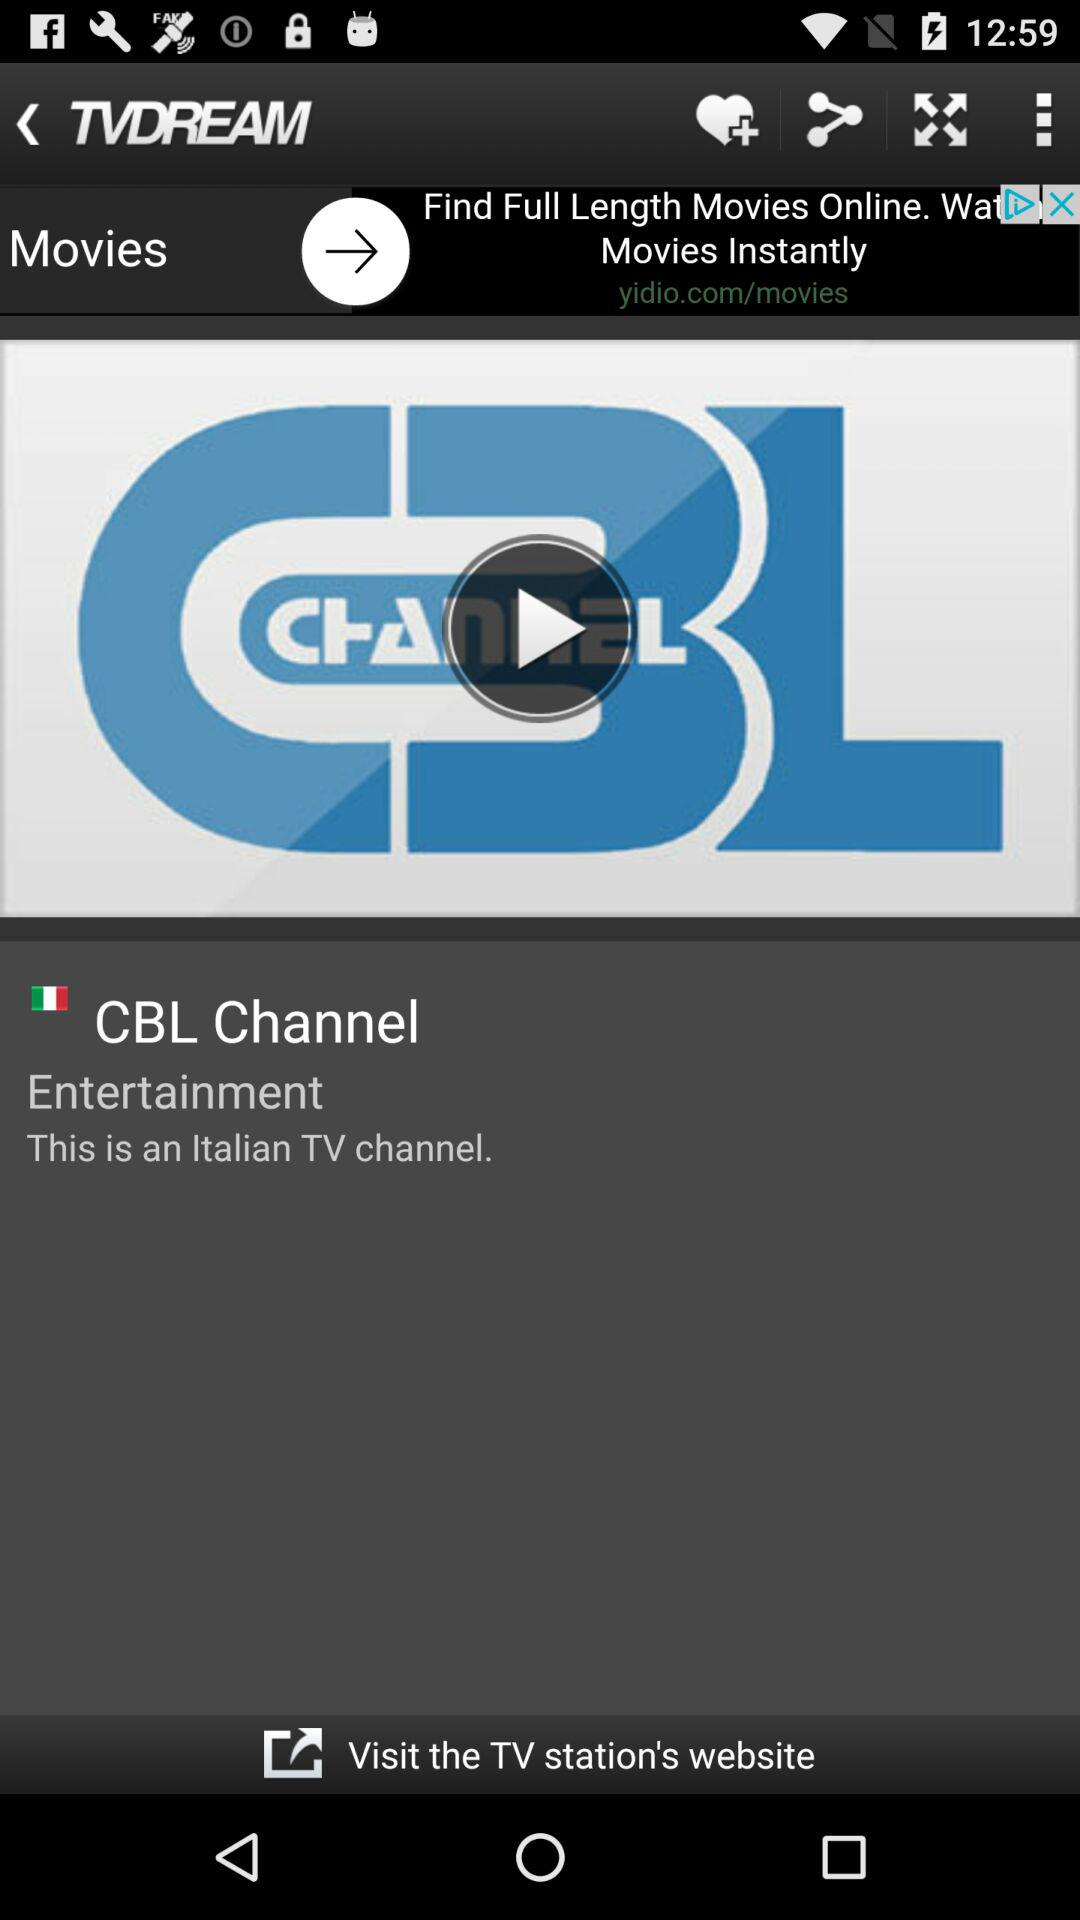What is the name of the application? The name of the application is "TVDREAM". 